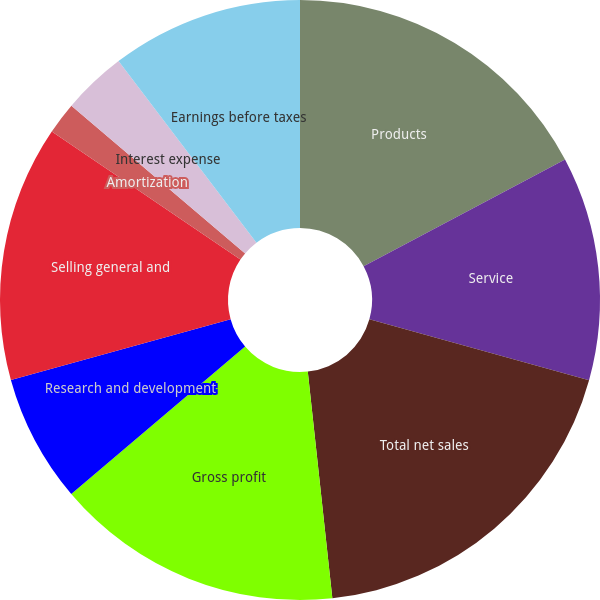Convert chart to OTSL. <chart><loc_0><loc_0><loc_500><loc_500><pie_chart><fcel>Products<fcel>Service<fcel>Total net sales<fcel>Gross profit<fcel>Research and development<fcel>Selling general and<fcel>Amortization<fcel>Interest expense<fcel>Other charges net<fcel>Earnings before taxes<nl><fcel>17.24%<fcel>12.07%<fcel>18.97%<fcel>15.52%<fcel>6.9%<fcel>13.79%<fcel>1.72%<fcel>3.45%<fcel>0.0%<fcel>10.34%<nl></chart> 